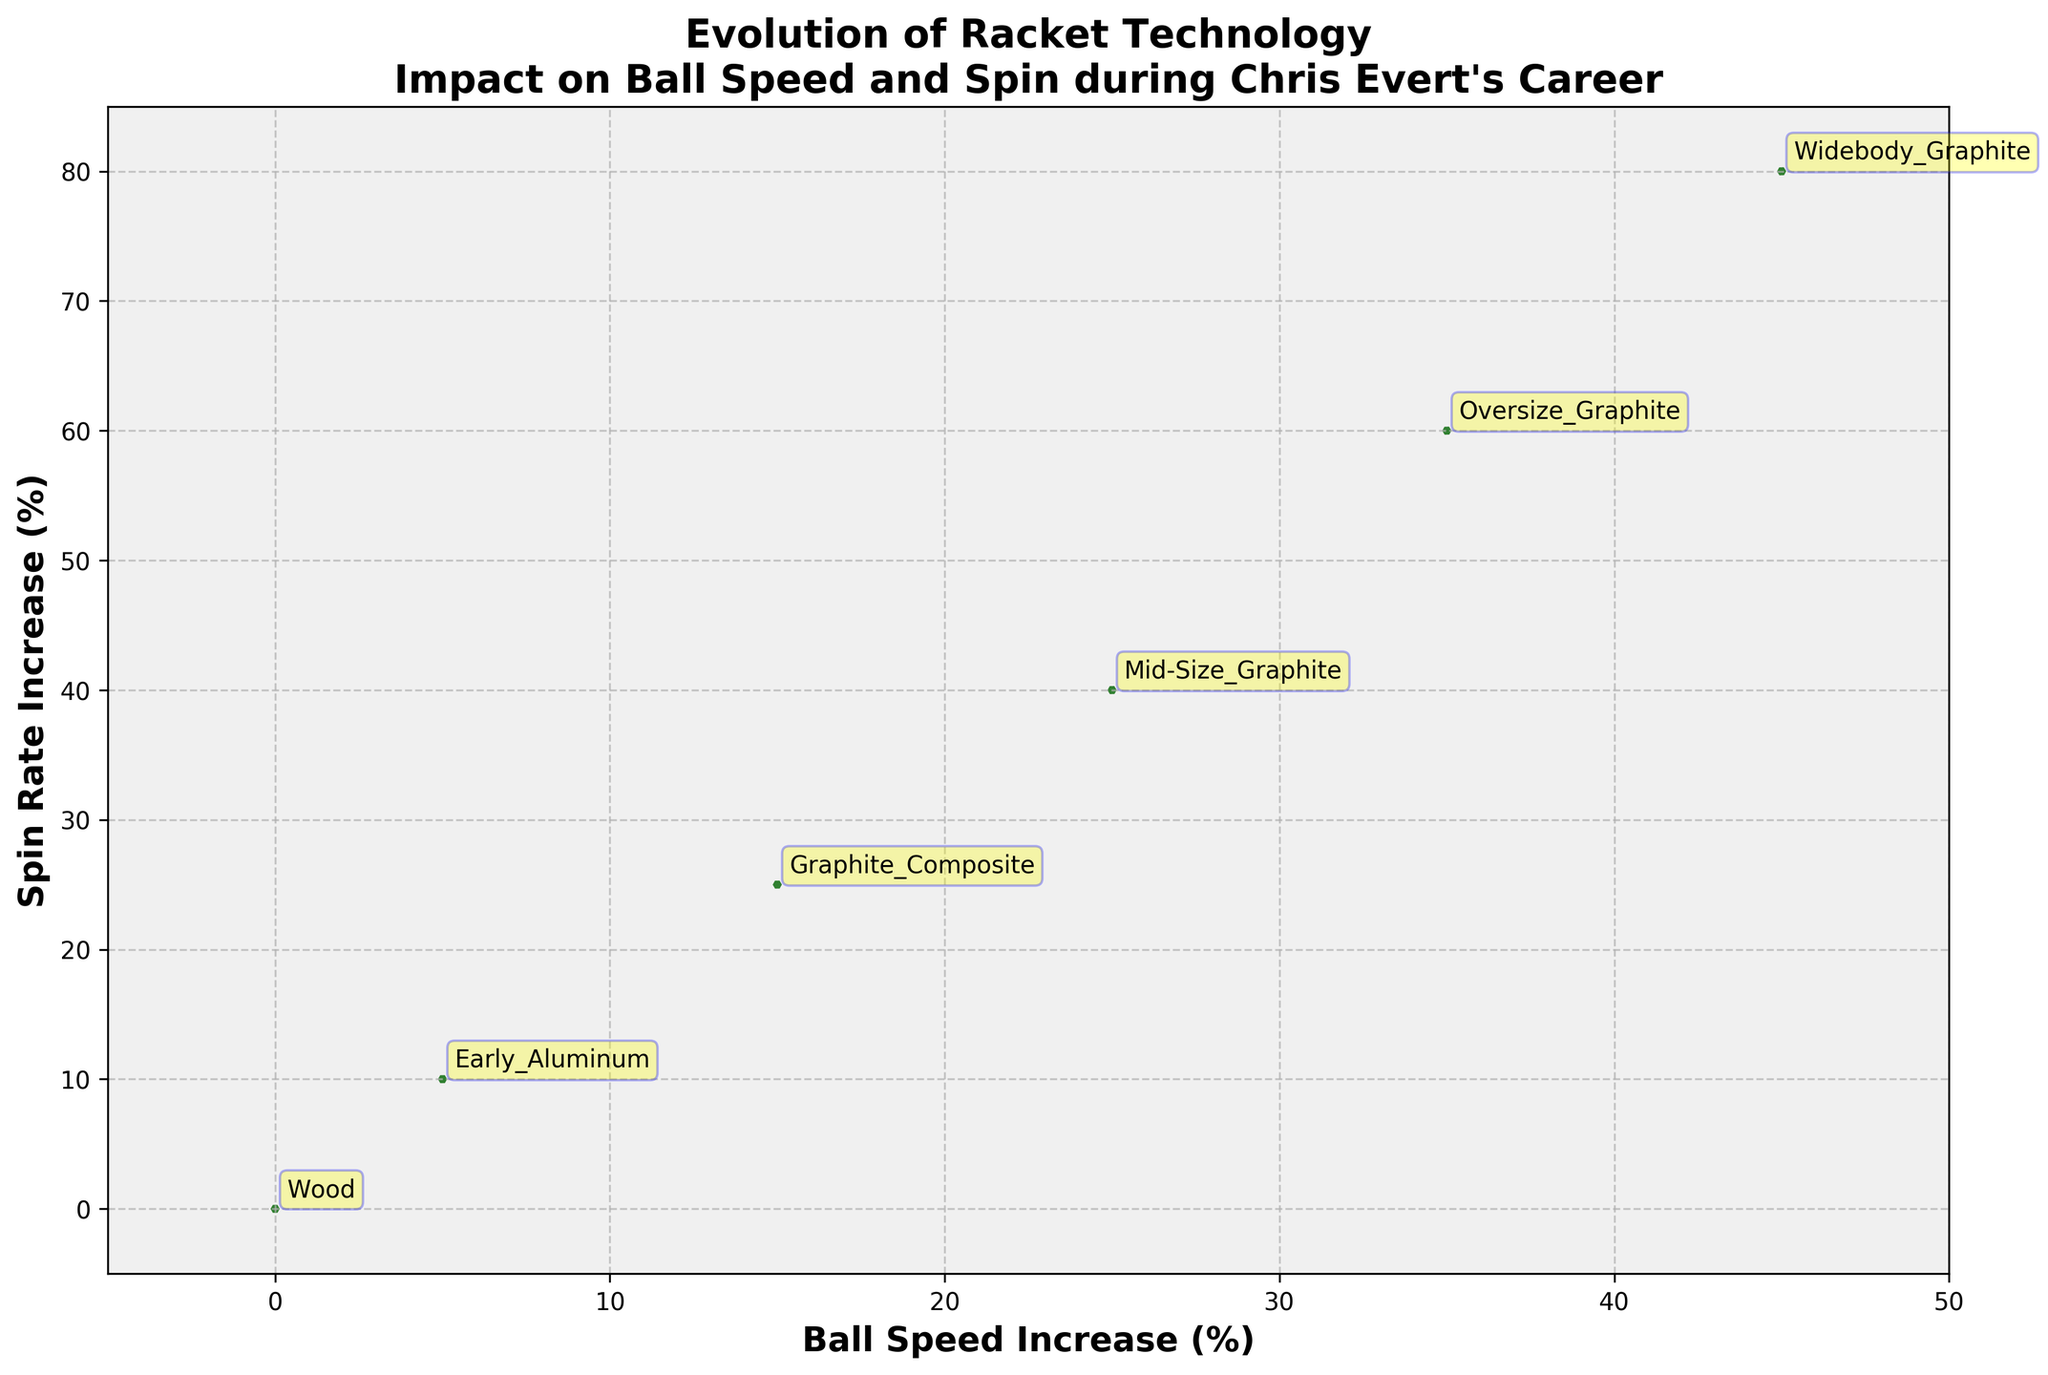What is the title of the figure? The title of the figure is displayed at the top and reads: "Evolution of Racket Technology Impact on Ball Speed and Spin during Chris Evert's Career."
Answer: Evolution of Racket Technology Impact on Ball Speed and Spin during Chris Evert's Career How many different racket types are listed in the figure? By observing the text annotations next to the data points, we can see six different racket types listed.
Answer: Six Which racket type shows the highest increase in ball speed? Look for the data point farthest to the right on the x-axis (Ball Speed Increase). The corresponding annotation shows that "Widebody_Graphite" racket type has the highest ball speed increase.
Answer: Widebody_Graphite Which racket type has experienced the highest increase in spin rate over the years? By examining the data point farthest up on the y-axis (Spin Rate Increase), the "Widebody_Graphite" racket type shows the highest increase.
Answer: Widebody_Graphite What are the respective increases in ball speed and spin rate for the Mid-Size Graphite racket? Locate the "Mid-Size_Graphite" annotation and read its x and y-coordinate values from the axes: Ball Speed Increase is 25%, and Spin Rate Increase is 40%.
Answer: Ball Speed Increase: 25%, Spin Rate Increase: 40% What is the average increase in ball speed for all racket types? Add all the ball speed increases (0, 5, 15, 25, 35, 45) and divide by the number of racket types (6): (0 + 5 + 15 + 25 + 35 + 45) / 6. The total is 125, so the average is 125 / 6.
Answer: 20.83% Which racket type did Chris Evert start her career with? According to the year provided in the annotations, the racket type associated with 1971 is "Wood."
Answer: Wood Between which years did the most significant jump in ball speed increase occur? To find the biggest difference in ball speed increase, compare consecutive values: (1971-1975): 5, (1975-1980): 10, (1980-1985): 10, (1985-1990): 10, (1990-1995): 10. The largest jump was between 1990 and 1995, which equals 10%.
Answer: 1990 and 1995 